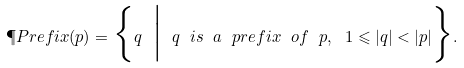<formula> <loc_0><loc_0><loc_500><loc_500>\P P r e f i x ( p ) = \Big \{ q \ \Big | \ q \ i s \ a \ p r e f i x \ o f \ p , \ 1 \leqslant | q | < | p | \Big \} .</formula> 